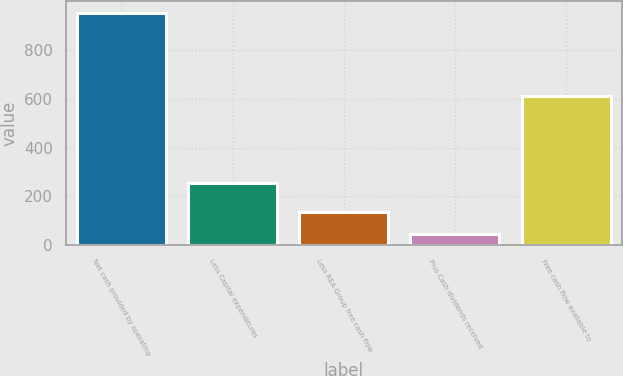<chart> <loc_0><loc_0><loc_500><loc_500><bar_chart><fcel>Net cash provided by operating<fcel>Less Capital expenditures<fcel>Less REA Group free cash flow<fcel>Plus Cash dividends received<fcel>Free cash flow available to<nl><fcel>952<fcel>256<fcel>135.7<fcel>45<fcel>610<nl></chart> 